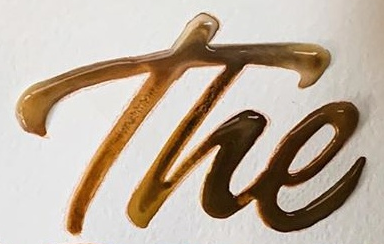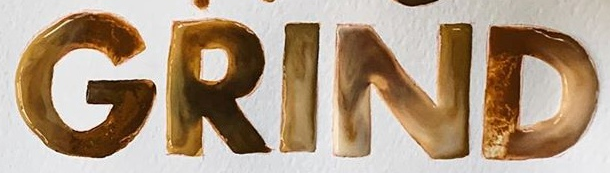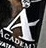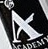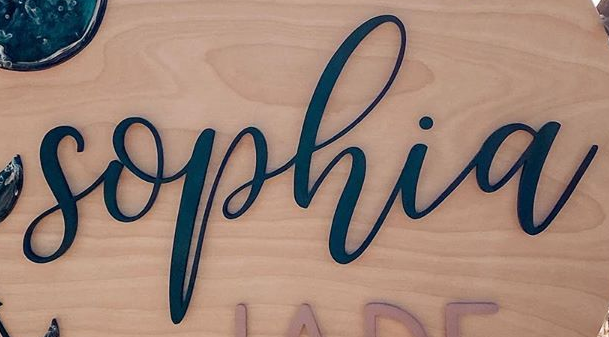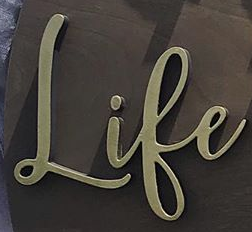Transcribe the words shown in these images in order, separated by a semicolon. The; GRIND; A; A; sophia; Life 